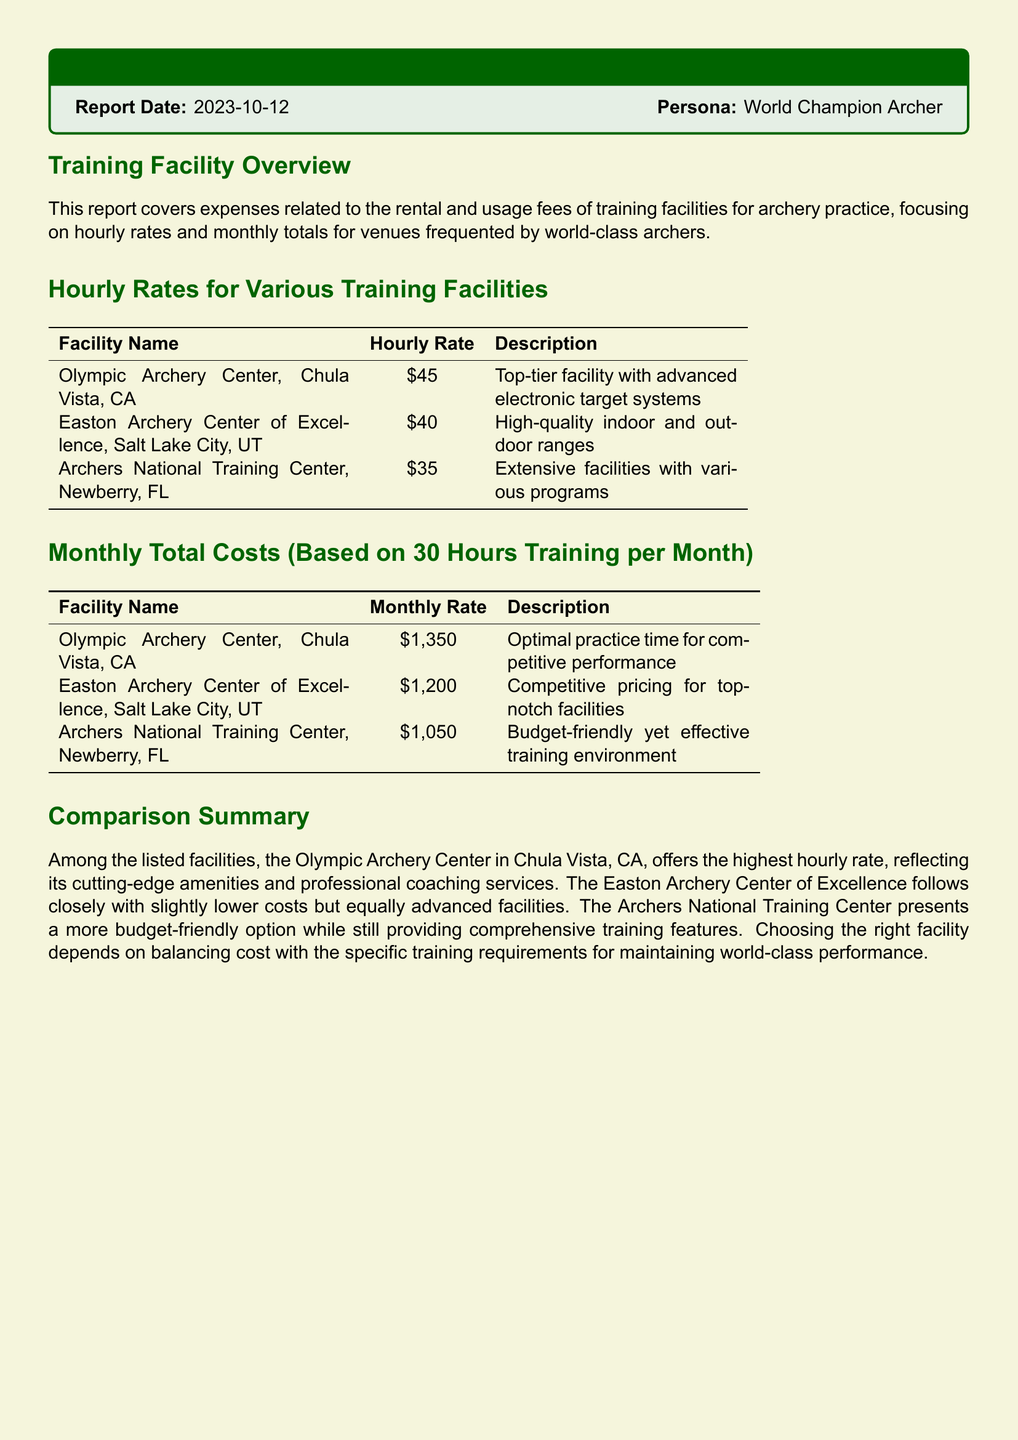What is the report date? The report date is specified at the beginning of the document under the report header.
Answer: 2023-10-12 What is the hourly rate for the Olympic Archery Center? The hourly rate is found in the hourly rates table listed for the Olympic Archery Center.
Answer: $45 What are the total monthly training costs for the Archers National Training Center? The monthly total costs are provided in a separate table, specifically for the Archers National Training Center.
Answer: $1,050 Which facility has the second highest hourly rate? To determine this, one needs to compare the hourly rates from the given facilities.
Answer: Easton Archery Center of Excellence What is the description for the Easton Archery Center of Excellence? The description is provided next to the hourly rate under the hourly rates section.
Answer: High-quality indoor and outdoor ranges How many hours of training are assumed for the monthly totals? This information is listed in the header relative to the monthly total costs.
Answer: 30 hours Which facility offers a budget-friendly training environment? This can be inferred from the summary of the monthly total costs.
Answer: Archers National Training Center What is the total monthly cost for training at the Easton Archery Center of Excellence? The monthly cost is found in the monthly total costs table for that facility.
Answer: $1,200 What does the comparison summary suggest about the Olympic Archery Center? The summary provides insights regarding its relative ranking among facilities based on various factors.
Answer: Highest hourly rate 